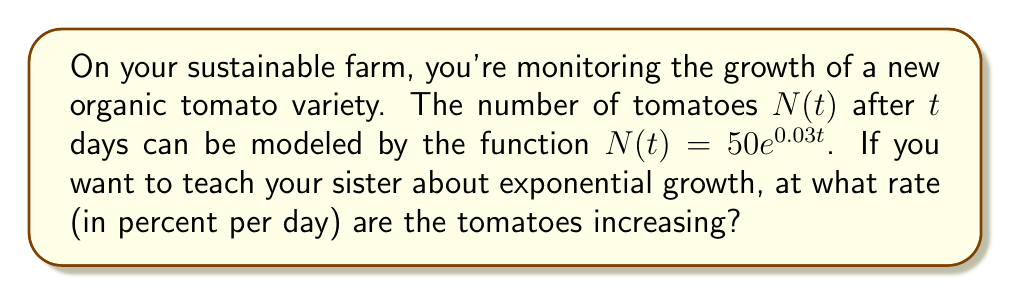What is the answer to this math problem? To find the growth rate, we need to analyze the given exponential function:

$N(t) = 50e^{0.03t}$

In general, an exponential growth function has the form:

$f(t) = ae^{rt}$

where $r$ is the continuous growth rate.

In our case, $a = 50$ and $r = 0.03$.

The continuous growth rate $r = 0.03$ represents the proportional increase per unit time (in this case, per day). However, we typically express growth rates as percentages.

To convert the continuous growth rate to a percentage:

1. Multiply by 100 to convert to a percentage:
   $0.03 \times 100 = 3\%$

Therefore, the tomatoes are growing at a rate of 3% per day.

Note: This is the instantaneous growth rate. The actual number of tomatoes increases continuously according to the exponential function, not by exactly 3% each day.
Answer: The tomatoes are increasing at a rate of 3% per day. 